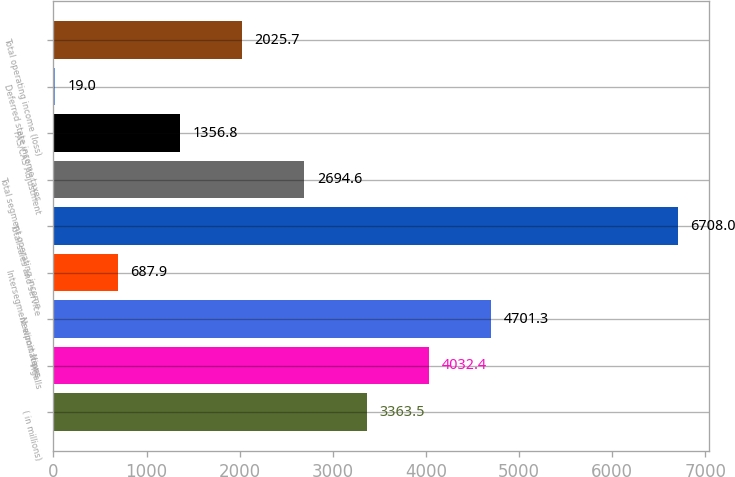Convert chart. <chart><loc_0><loc_0><loc_500><loc_500><bar_chart><fcel>( in millions)<fcel>Ingalls<fcel>Newport News<fcel>Intersegment eliminations<fcel>Total sales and service<fcel>Total segment operating income<fcel>FAS/CAS Adjustment<fcel>Deferred state income taxes<fcel>Total operating income (loss)<nl><fcel>3363.5<fcel>4032.4<fcel>4701.3<fcel>687.9<fcel>6708<fcel>2694.6<fcel>1356.8<fcel>19<fcel>2025.7<nl></chart> 